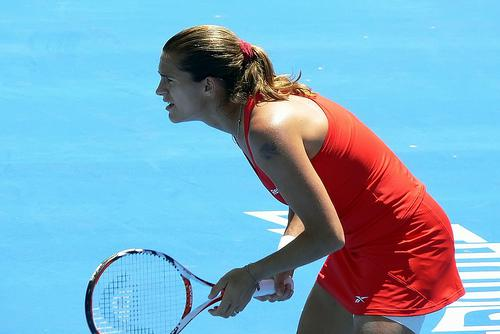Question: what is red?
Choices:
A. The chair.
B. Player's outfit.
C. The wall.
D. The ball.
Answer with the letter. Answer: B Question: why is a woman holding a racket?
Choices:
A. To play table tennis.
B. To play tennis.
C. For the player.
D. To play bad mitton.
Answer with the letter. Answer: B Question: how many rackets are there?
Choices:
A. 12.
B. 13.
C. 5.
D. Only one.
Answer with the letter. Answer: D Question: who has a ponytail?
Choices:
A. The little girl.
B. Softball player.
C. Tennis player.
D. The hippie.
Answer with the letter. Answer: C Question: where was the photo taken?
Choices:
A. At a tennis court.
B. At the game.
C. During class.
D. In the bedroom.
Answer with the letter. Answer: A 